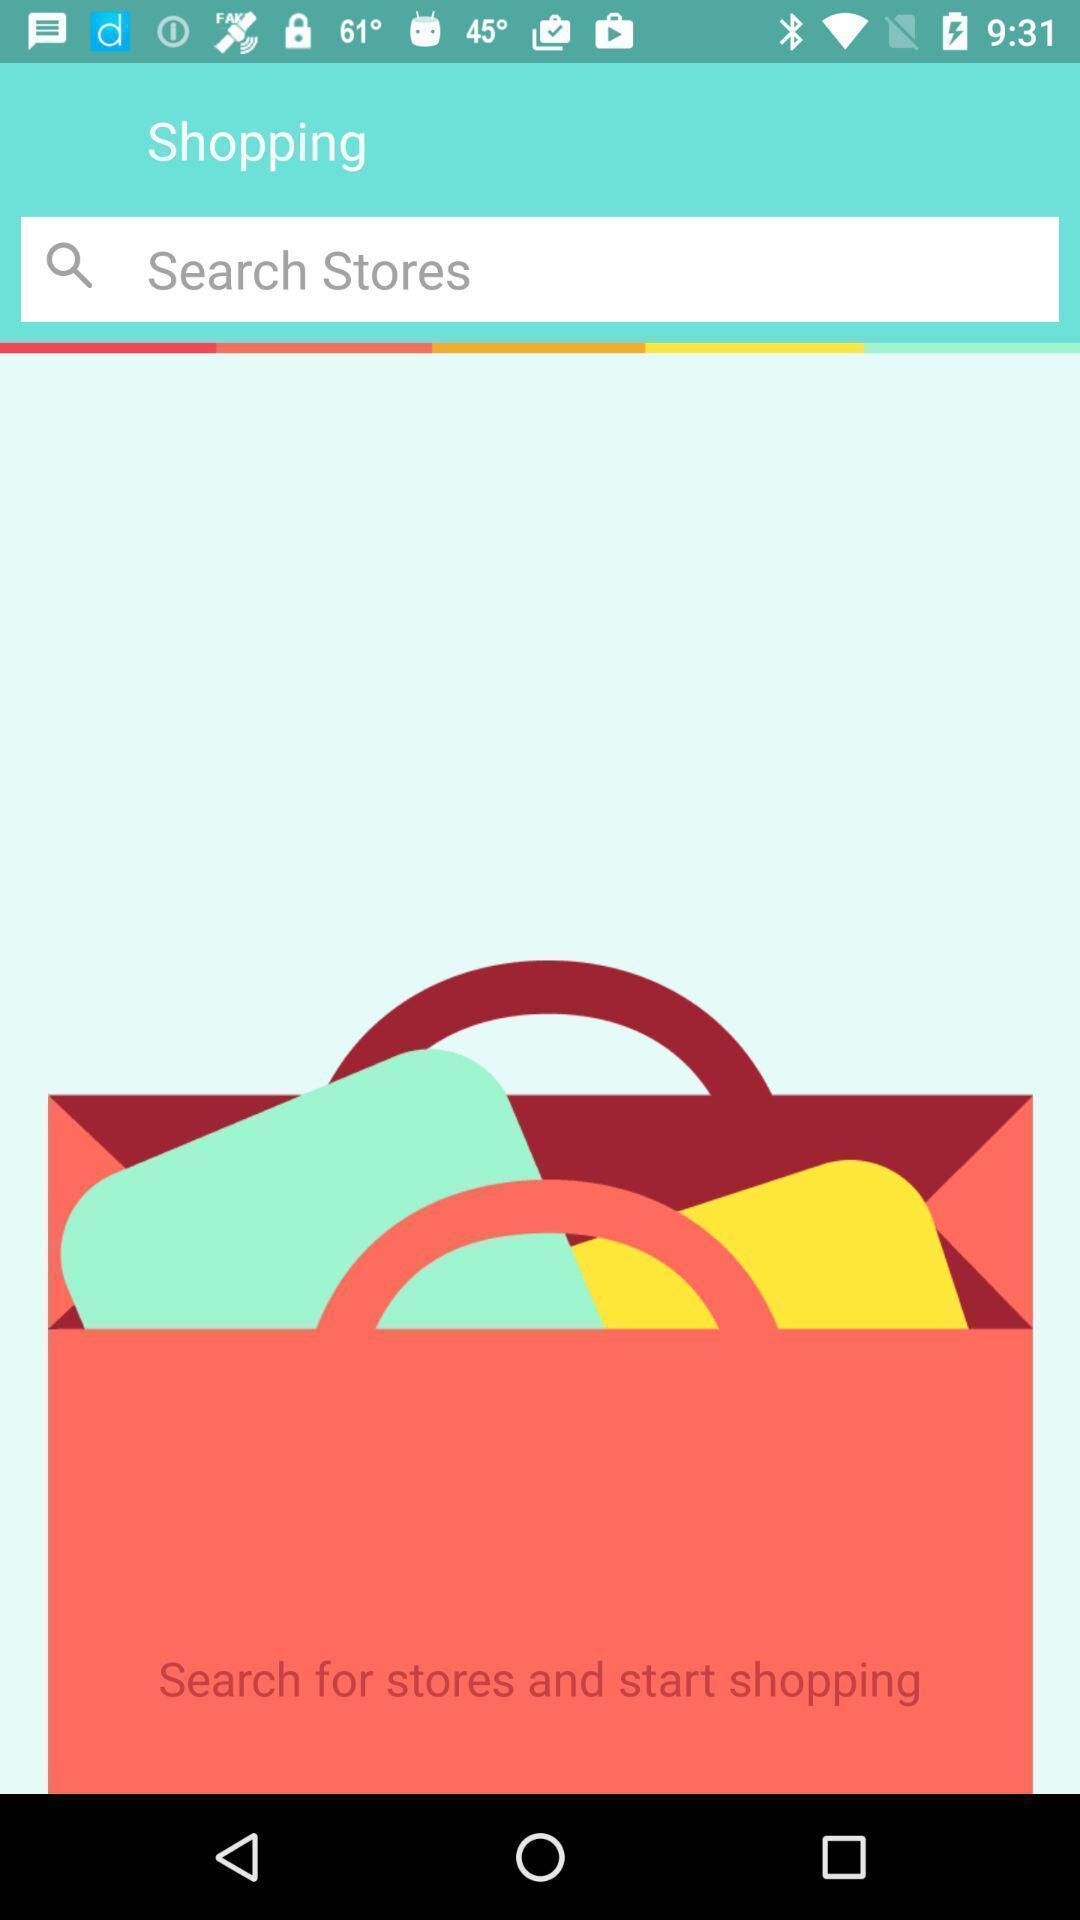Please provide a description for this image. Search page for searching a stores for shopping. 